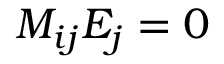<formula> <loc_0><loc_0><loc_500><loc_500>M _ { i j } E _ { j } = 0</formula> 